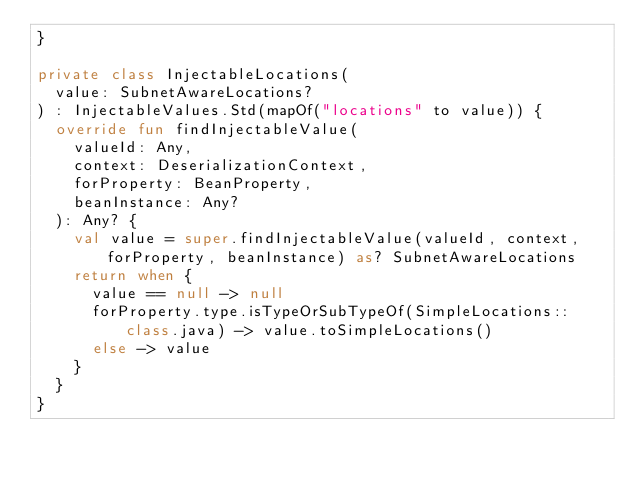<code> <loc_0><loc_0><loc_500><loc_500><_Kotlin_>}

private class InjectableLocations(
  value: SubnetAwareLocations?
) : InjectableValues.Std(mapOf("locations" to value)) {
  override fun findInjectableValue(
    valueId: Any,
    context: DeserializationContext,
    forProperty: BeanProperty,
    beanInstance: Any?
  ): Any? {
    val value = super.findInjectableValue(valueId, context, forProperty, beanInstance) as? SubnetAwareLocations
    return when {
      value == null -> null
      forProperty.type.isTypeOrSubTypeOf(SimpleLocations::class.java) -> value.toSimpleLocations()
      else -> value
    }
  }
}
</code> 